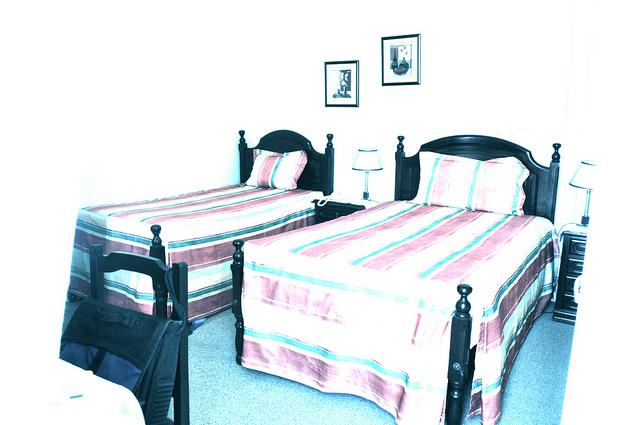How many people can sleep in this room?

Choices:
A) six
B) four
C) two
D) eight two 